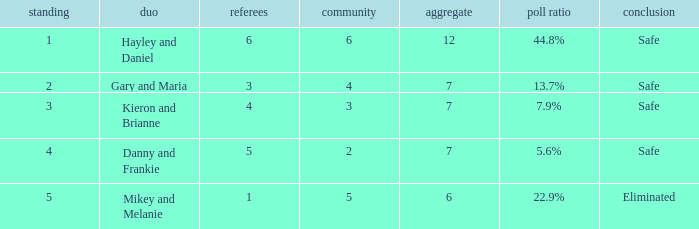Would you mind parsing the complete table? {'header': ['standing', 'duo', 'referees', 'community', 'aggregate', 'poll ratio', 'conclusion'], 'rows': [['1', 'Hayley and Daniel', '6', '6', '12', '44.8%', 'Safe'], ['2', 'Gary and Maria', '3', '4', '7', '13.7%', 'Safe'], ['3', 'Kieron and Brianne', '4', '3', '7', '7.9%', 'Safe'], ['4', 'Danny and Frankie', '5', '2', '7', '5.6%', 'Safe'], ['5', 'Mikey and Melanie', '1', '5', '6', '22.9%', 'Eliminated']]} What is the number of public that was there when the vote percentage was 22.9%? 1.0. 